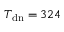<formula> <loc_0><loc_0><loc_500><loc_500>T _ { d n } = 3 2 4</formula> 